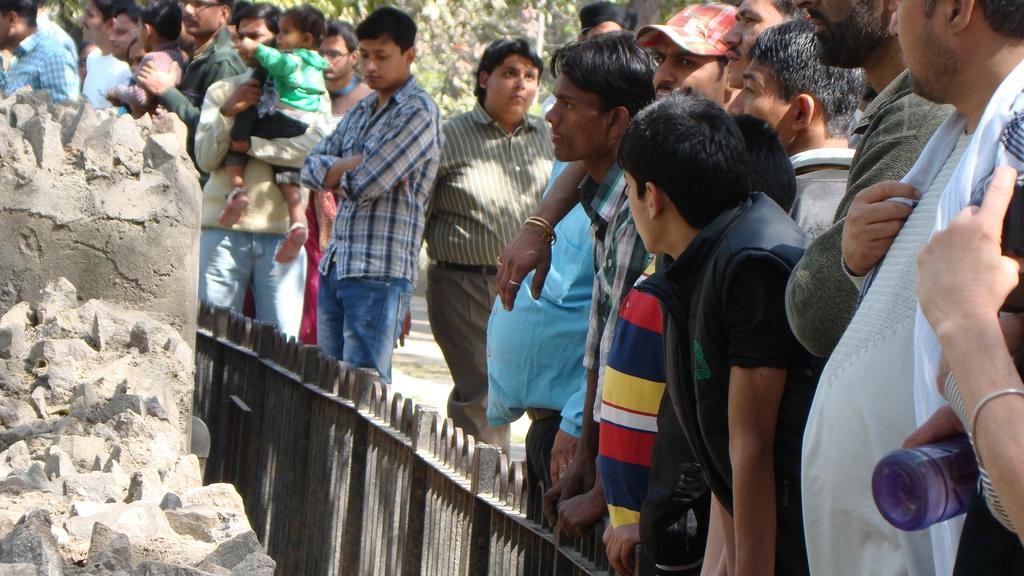Can you describe this image briefly? In this image I can see the group of people with different color dresses and one person is holding the bottle. In-front of these people I can see the railing and the rock. In the background I can see many trees. 